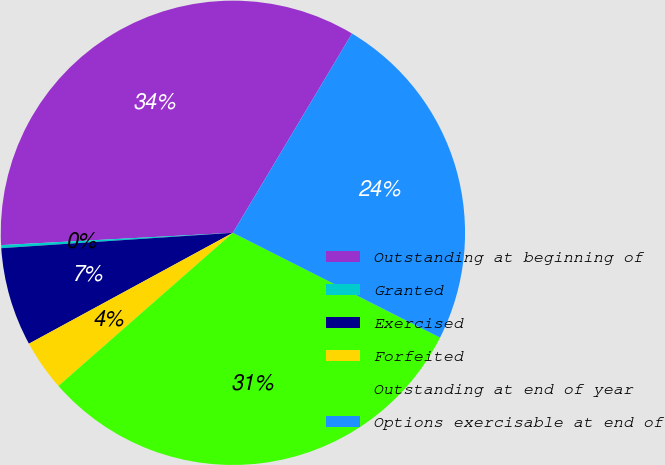Convert chart. <chart><loc_0><loc_0><loc_500><loc_500><pie_chart><fcel>Outstanding at beginning of<fcel>Granted<fcel>Exercised<fcel>Forfeited<fcel>Outstanding at end of year<fcel>Options exercisable at end of<nl><fcel>34.42%<fcel>0.21%<fcel>6.87%<fcel>3.54%<fcel>31.08%<fcel>23.88%<nl></chart> 